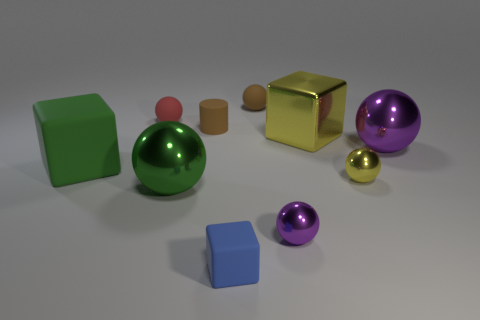Subtract all tiny matte spheres. How many spheres are left? 4 Subtract all yellow spheres. How many spheres are left? 5 Subtract all blue balls. Subtract all green cylinders. How many balls are left? 6 Subtract all cylinders. How many objects are left? 9 Add 8 small yellow metal cylinders. How many small yellow metal cylinders exist? 8 Subtract 1 brown cylinders. How many objects are left? 9 Subtract all green matte cubes. Subtract all large matte cylinders. How many objects are left? 9 Add 2 small yellow shiny objects. How many small yellow shiny objects are left? 3 